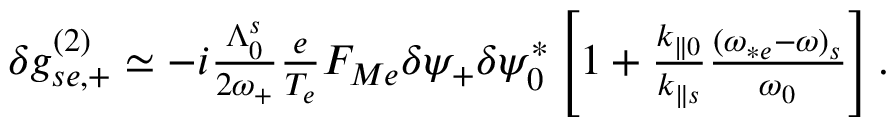Convert formula to latex. <formula><loc_0><loc_0><loc_500><loc_500>\begin{array} { r } { \delta g _ { s e , + } ^ { ( 2 ) } \simeq - i \frac { \Lambda _ { 0 } ^ { s } } { 2 \omega _ { + } } \frac { e } { T _ { e } } F _ { M e } \delta \psi _ { + } \delta \psi _ { 0 } ^ { * } \left [ 1 + \frac { k _ { \| 0 } } { k _ { \| s } } \frac { ( \omega _ { * e } - \omega ) _ { s } } { \omega _ { 0 } } \right ] . } \end{array}</formula> 